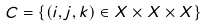<formula> <loc_0><loc_0><loc_500><loc_500>C = \{ ( i , j , k ) \in X \times X \times X \}</formula> 